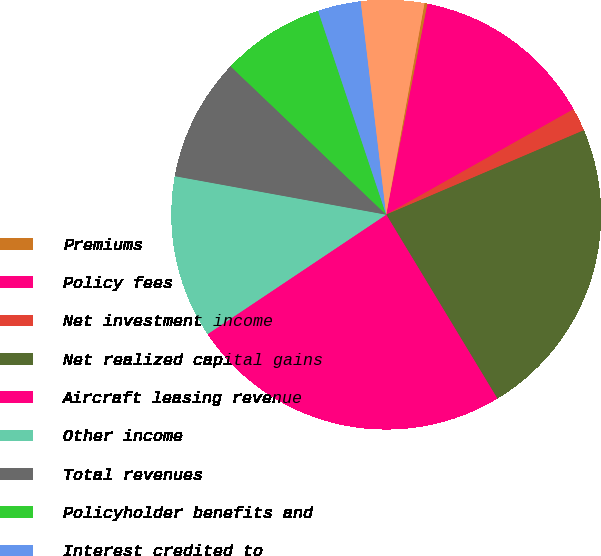Convert chart to OTSL. <chart><loc_0><loc_0><loc_500><loc_500><pie_chart><fcel>Premiums<fcel>Policy fees<fcel>Net investment income<fcel>Net realized capital gains<fcel>Aircraft leasing revenue<fcel>Other income<fcel>Total revenues<fcel>Policyholder benefits and<fcel>Interest credited to<fcel>Amortization of deferred<nl><fcel>0.23%<fcel>13.76%<fcel>1.74%<fcel>22.77%<fcel>24.27%<fcel>12.25%<fcel>9.25%<fcel>7.75%<fcel>3.24%<fcel>4.74%<nl></chart> 